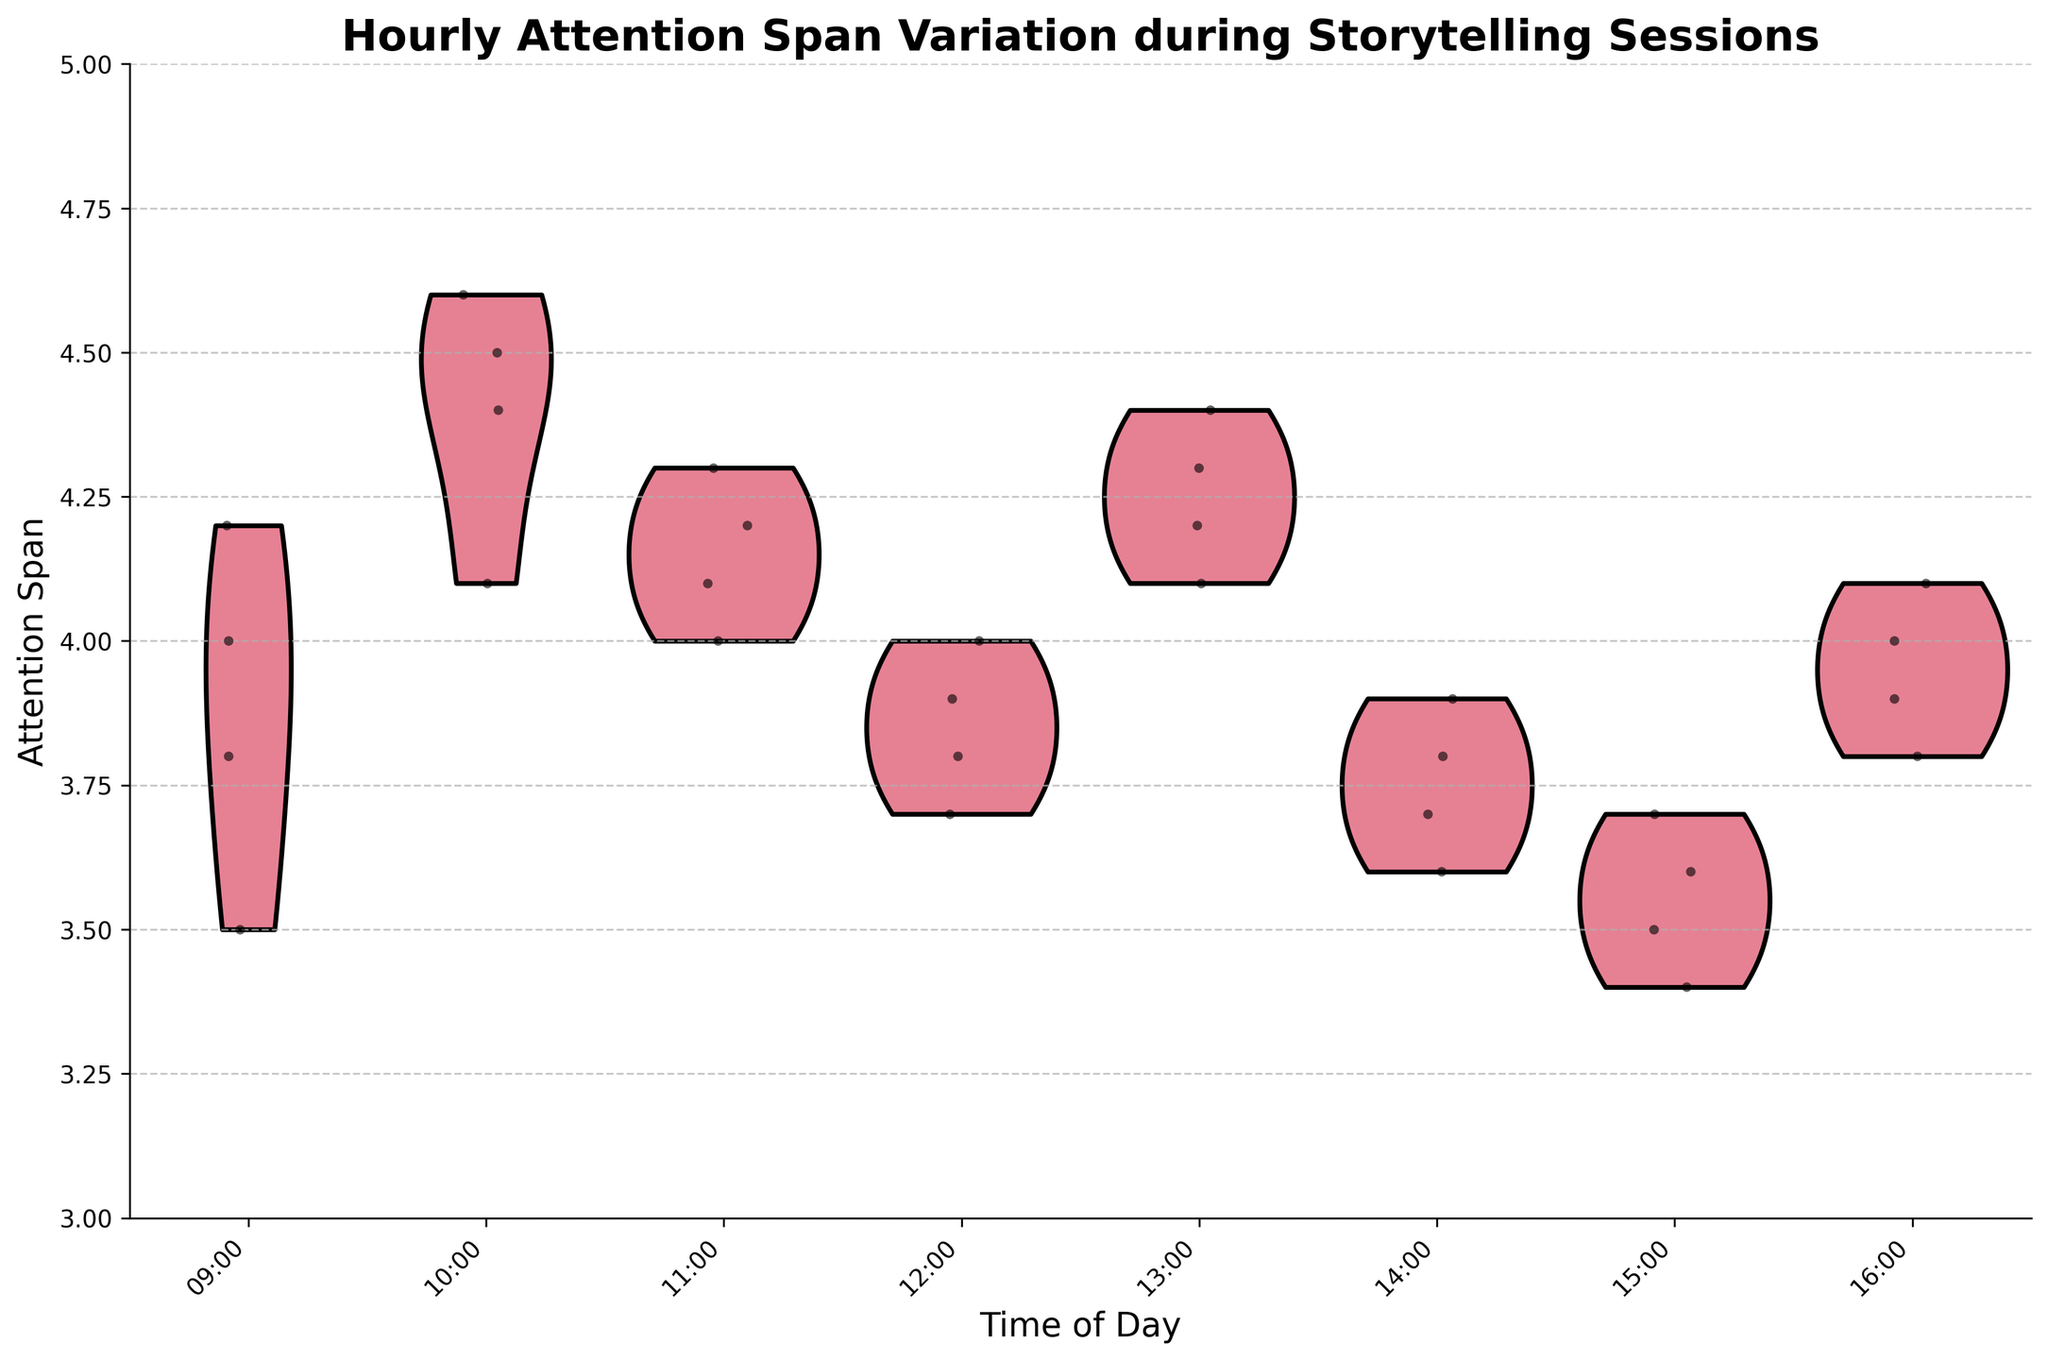What is the title of the figure? The title is typically placed at the top of the figure and is usually in a larger or bold font. It directly states "Hourly Attention Span Variation during Storytelling Sessions".
Answer: Hourly Attention Span Variation during Storytelling Sessions What does the y-axis represent? The y-axis label is provided on the y-axis of the graph and it states "Attention Span". This axis represents the attention span measurements.
Answer: Attention Span At what time of the day is the attention span variability (spread) the largest? The spread of the data points within each violin plot indicates the variability. We look at each hour's width of the violin plot to identify the one with the largest spread; "10:00" appears to have the most spread.
Answer: 10:00 Which time slot shows the highest peak in attention span values? The topmost point on the violin plot for each time indicates the highest attention span values. The time slot with the highest topmost point is "10:00".
Answer: 10:00 What is the median attention span at 14:00? The median of a violin plot is usually at the center of the width of the violin. The central tendency point observed at "14:00" is between 3.7 and 3.8.
Answer: 3.75 Comparing 09:00 and 15:00, which time has a higher median attention span? Observe the center line (widest part) of the violin plots at "09:00" and "15:00". The median attention span at "09:00" is around 3.9, while at "15:00" it is around 3.6.
Answer: 09:00 How does the attention span at 13:00 compare to that at 16:00? Look at the overall spread and central tendencies of the violin plots at "13:00" and "16:00". The median values for both are similar, approximately at 4.2, but "16:00" shows a slight drop at the lower end.
Answer: 13:00 and 16:00 are similar What colors are used for jittered points in the figure? The jittered points are overlaid in black.
Answer: Black How many data points are there for each time slot? Count the number of jittered points (small black dots) in each time slot. Each time slot has exactly 4 data points.
Answer: 4 What time of the day has the lowest overall attention span recorded? The lowest point on the violin plot represents the minimal recorded value. At "15:00", the lowest attention span is 3.4.
Answer: 15:00 